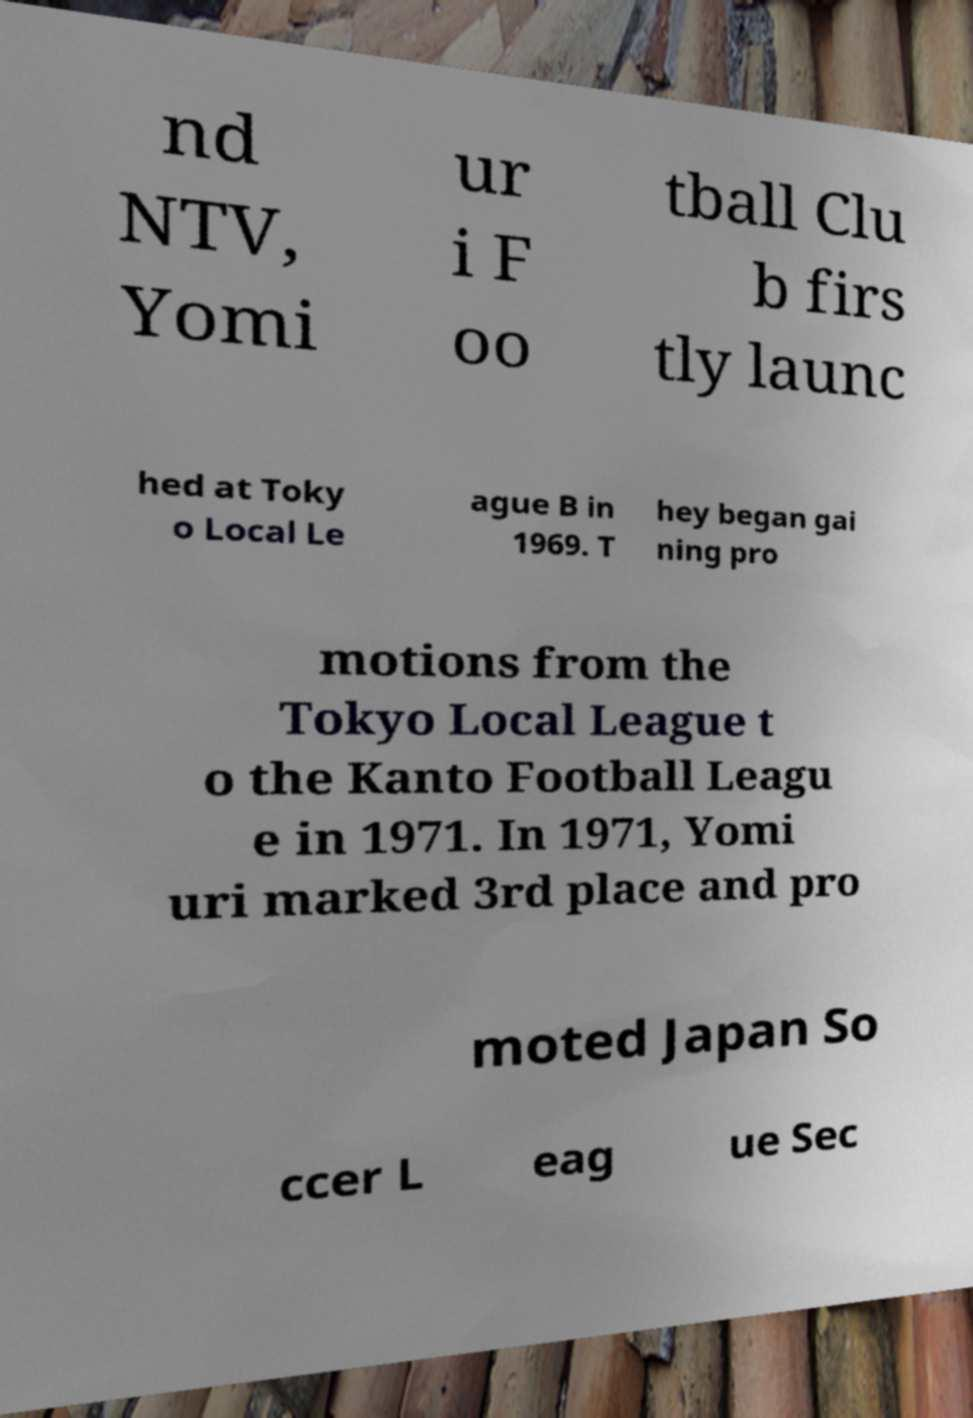What messages or text are displayed in this image? I need them in a readable, typed format. nd NTV, Yomi ur i F oo tball Clu b firs tly launc hed at Toky o Local Le ague B in 1969. T hey began gai ning pro motions from the Tokyo Local League t o the Kanto Football Leagu e in 1971. In 1971, Yomi uri marked 3rd place and pro moted Japan So ccer L eag ue Sec 